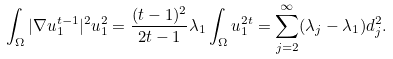Convert formula to latex. <formula><loc_0><loc_0><loc_500><loc_500>\int _ { \Omega } | \nabla u _ { 1 } ^ { t - 1 } | ^ { 2 } u _ { 1 } ^ { 2 } = \frac { ( t - 1 ) ^ { 2 } } { 2 t - 1 } \lambda _ { 1 } \int _ { \Omega } u _ { 1 } ^ { 2 t } = \sum _ { j = 2 } ^ { \infty } ( \lambda _ { j } - \lambda _ { 1 } ) d _ { j } ^ { 2 } .</formula> 